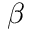<formula> <loc_0><loc_0><loc_500><loc_500>\beta</formula> 